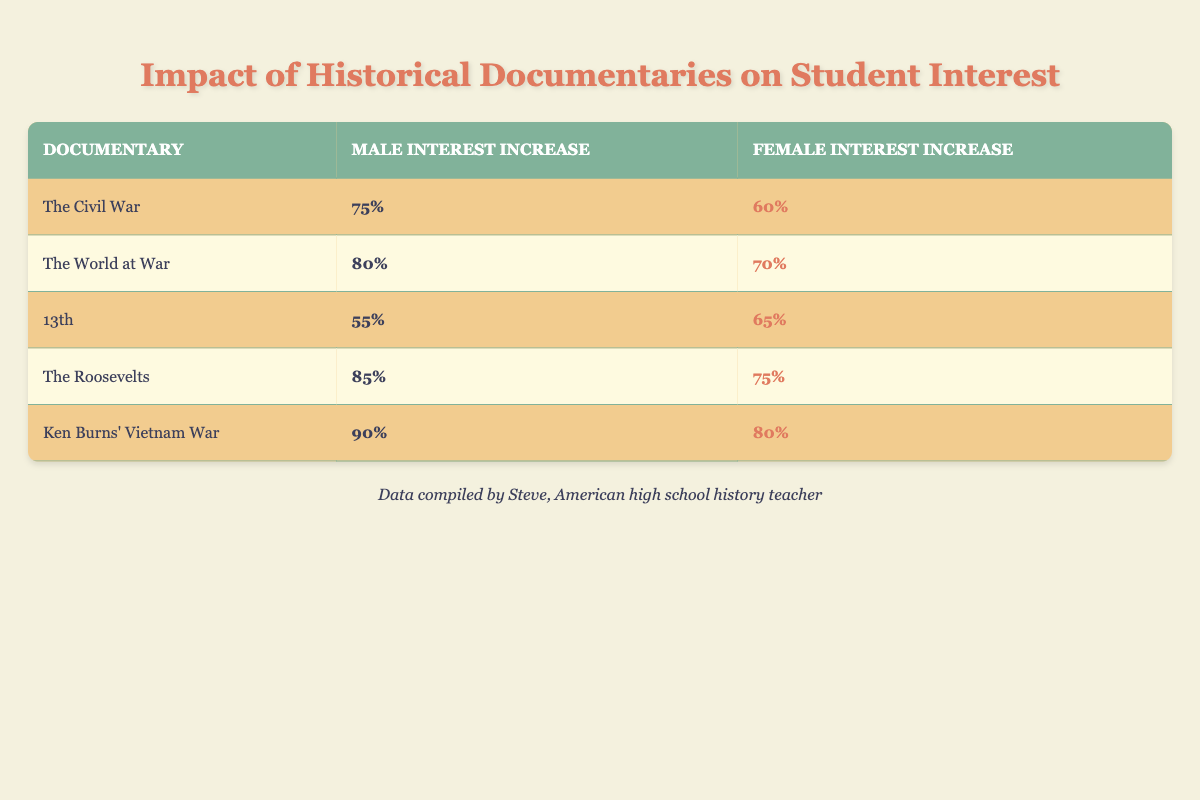What is the highest interest increase for male students among the documentaries listed? The highest interest increase for male students can be found by scanning through the 'Male Interest Increase' column. The values are 75%, 80%, 55%, 85%, and 90%. The maximum value among these is 90%.
Answer: 90% Which documentary had a greater interest increase for female students compared to male students? To find a documentary where the interest increase for female students is greater than for male students, we compare each pair of values. The interests for "13th" (65% for females vs. 55% for males) shows that females had a higher interest increase.
Answer: 13th What is the average interest increase for male students across all documentaries? We need to sum the male interest increases (75 + 80 + 55 + 85 + 90) = 385. Since there are 5 documentaries, we then divide this sum by 5. Therefore, the average is 385 / 5 = 77.
Answer: 77 True or False: The interest increase for "The Roosevelts" is higher for male students than the interest increase for "The Civil War". We compare the values for "The Roosevelts" (85% for males) and "The Civil War" (75% for males). Since 85% is greater than 75%, the statement is true.
Answer: True What is the difference in interest increase between the highest documentary for males and the highest for females? The highest interest for males is 90% (Ken Burns’ Vietnam War) and for females is 80% (Ken Burns’ Vietnam War). The difference is 90% - 80% = 10%.
Answer: 10% 